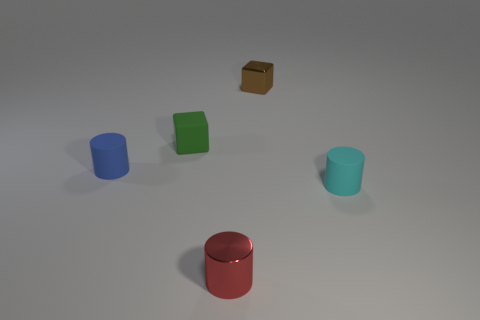How many cubes are the same size as the cyan thing?
Offer a very short reply. 2. Are there more tiny red things in front of the red cylinder than green matte cubes behind the metal cube?
Your answer should be very brief. No. There is a cyan thing that is the same size as the metallic cylinder; what is it made of?
Provide a short and direct response. Rubber. What shape is the small blue rubber object?
Your response must be concise. Cylinder. What number of gray things are either rubber objects or tiny metallic cubes?
Your answer should be very brief. 0. There is a red object that is made of the same material as the tiny brown object; what size is it?
Offer a very short reply. Small. Is the material of the cube that is on the right side of the green block the same as the small cylinder that is left of the green object?
Your answer should be very brief. No. What number of blocks are tiny red things or small blue rubber objects?
Your answer should be very brief. 0. There is a tiny shiny object behind the small metallic object that is in front of the rubber block; what number of small red cylinders are in front of it?
Give a very brief answer. 1. What material is the cyan object that is the same shape as the red metallic object?
Make the answer very short. Rubber. 